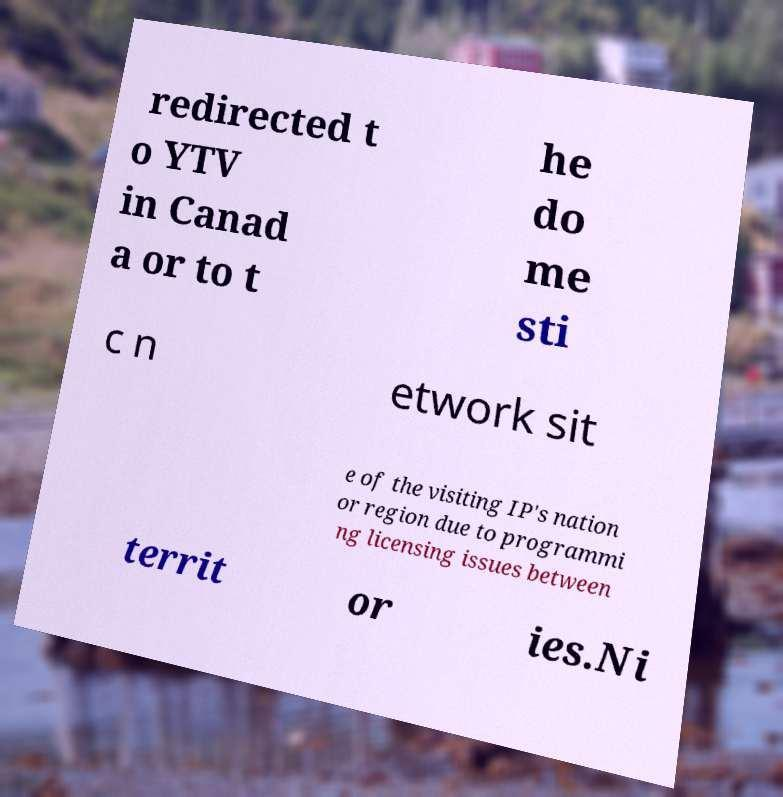Could you extract and type out the text from this image? redirected t o YTV in Canad a or to t he do me sti c n etwork sit e of the visiting IP's nation or region due to programmi ng licensing issues between territ or ies.Ni 